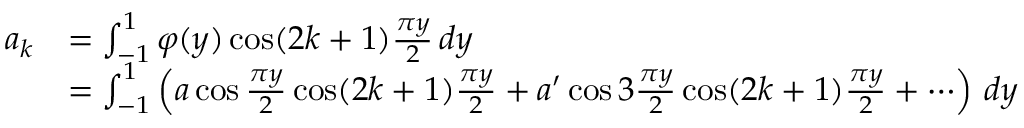<formula> <loc_0><loc_0><loc_500><loc_500>{ \begin{array} { r l } { a _ { k } } & { = \int _ { - 1 } ^ { 1 } \varphi ( y ) \cos ( 2 k + 1 ) { \frac { \pi y } { 2 } } \, d y } \\ & { = \int _ { - 1 } ^ { 1 } \left ( a \cos { \frac { \pi y } { 2 } } \cos ( 2 k + 1 ) { \frac { \pi y } { 2 } } + a ^ { \prime } \cos 3 { \frac { \pi y } { 2 } } \cos ( 2 k + 1 ) { \frac { \pi y } { 2 } } + \cdots \right ) \, d y } \end{array} }</formula> 